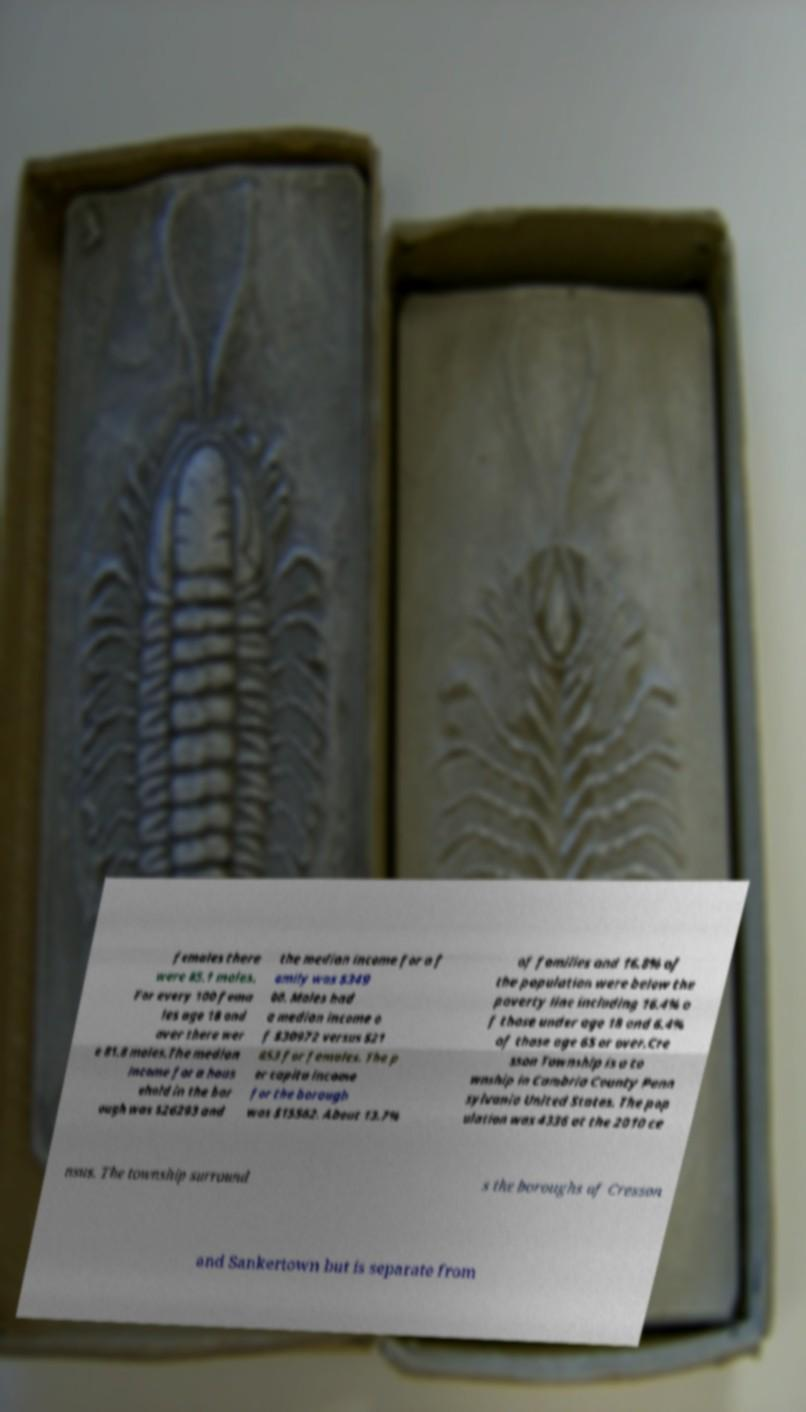For documentation purposes, I need the text within this image transcribed. Could you provide that? females there were 85.1 males. For every 100 fema les age 18 and over there wer e 81.8 males.The median income for a hous ehold in the bor ough was $26293 and the median income for a f amily was $349 00. Males had a median income o f $30972 versus $21 853 for females. The p er capita income for the borough was $15562. About 13.7% of families and 16.8% of the population were below the poverty line including 16.4% o f those under age 18 and 6.4% of those age 65 or over.Cre sson Township is a to wnship in Cambria County Penn sylvania United States. The pop ulation was 4336 at the 2010 ce nsus. The township surround s the boroughs of Cresson and Sankertown but is separate from 